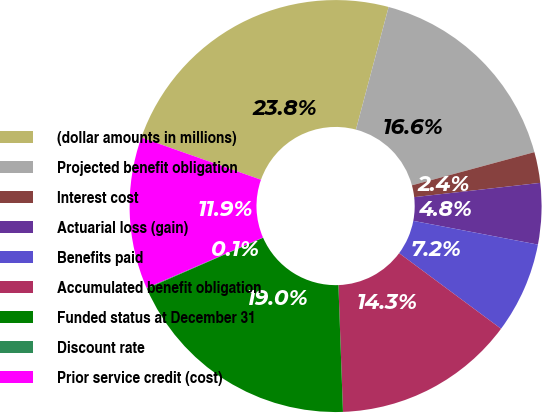Convert chart to OTSL. <chart><loc_0><loc_0><loc_500><loc_500><pie_chart><fcel>(dollar amounts in millions)<fcel>Projected benefit obligation<fcel>Interest cost<fcel>Actuarial loss (gain)<fcel>Benefits paid<fcel>Accumulated benefit obligation<fcel>Funded status at December 31<fcel>Discount rate<fcel>Prior service credit (cost)<nl><fcel>23.75%<fcel>16.64%<fcel>2.42%<fcel>4.79%<fcel>7.16%<fcel>14.27%<fcel>19.01%<fcel>0.05%<fcel>11.9%<nl></chart> 